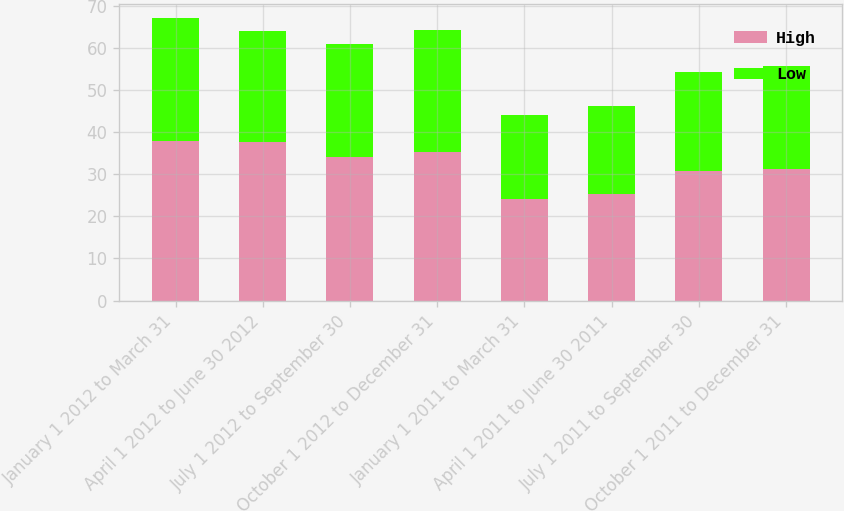<chart> <loc_0><loc_0><loc_500><loc_500><stacked_bar_chart><ecel><fcel>January 1 2012 to March 31<fcel>April 1 2012 to June 30 2012<fcel>July 1 2012 to September 30<fcel>October 1 2012 to December 31<fcel>January 1 2011 to March 31<fcel>April 1 2011 to June 30 2011<fcel>July 1 2011 to September 30<fcel>October 1 2011 to December 31<nl><fcel>High<fcel>37.79<fcel>37.65<fcel>34<fcel>35.3<fcel>24.19<fcel>25.22<fcel>30.75<fcel>31.16<nl><fcel>Low<fcel>29.26<fcel>26.22<fcel>26.88<fcel>29<fcel>19.78<fcel>21<fcel>23.41<fcel>24.57<nl></chart> 